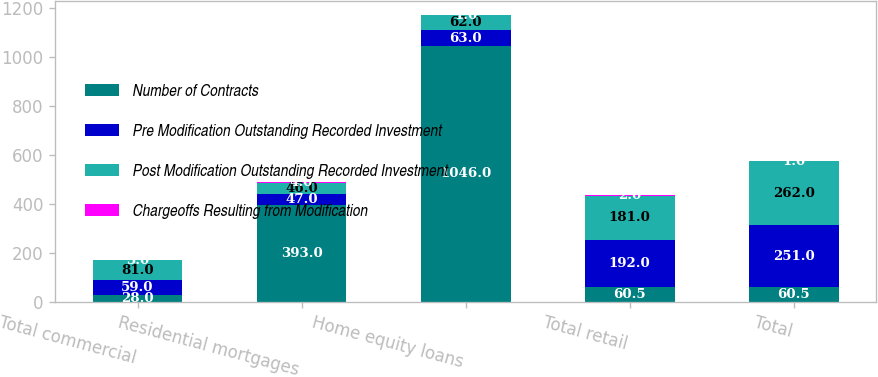Convert chart to OTSL. <chart><loc_0><loc_0><loc_500><loc_500><stacked_bar_chart><ecel><fcel>Total commercial<fcel>Residential mortgages<fcel>Home equity loans<fcel>Total retail<fcel>Total<nl><fcel>Number of Contracts<fcel>28<fcel>393<fcel>1046<fcel>60.5<fcel>60.5<nl><fcel>Pre Modification Outstanding Recorded Investment<fcel>59<fcel>47<fcel>63<fcel>192<fcel>251<nl><fcel>Post Modification Outstanding Recorded Investment<fcel>81<fcel>46<fcel>62<fcel>181<fcel>262<nl><fcel>Chargeoffs Resulting from Modification<fcel>3<fcel>4<fcel>1<fcel>2<fcel>1<nl></chart> 